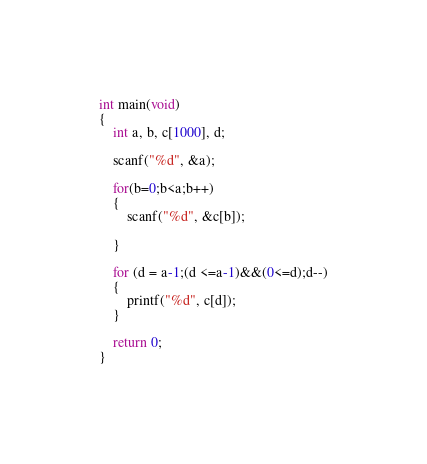Convert code to text. <code><loc_0><loc_0><loc_500><loc_500><_C_>int main(void)
{
    int a, b, c[1000], d;

    scanf("%d", &a);
    
    for(b=0;b<a;b++)
    {
        scanf("%d", &c[b]);

    }

    for (d = a-1;(d <=a-1)&&(0<=d);d--)
    {
        printf("%d", c[d]);
    }

    return 0;
}

</code> 